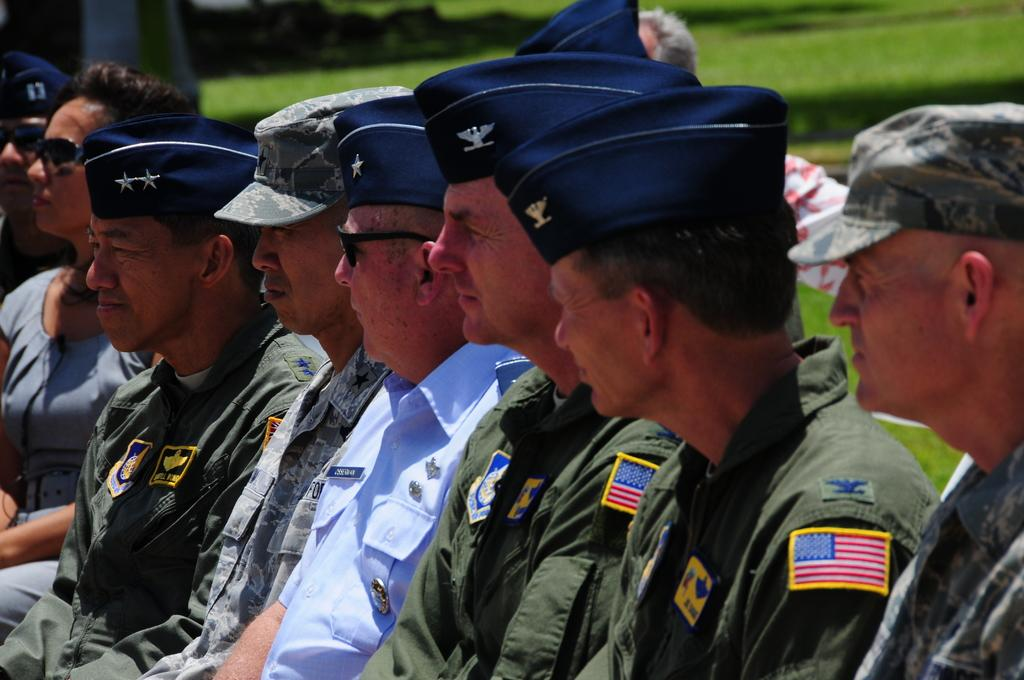How many people are in the image? There are multiple people in the image. What are the people doing in the image? The people are sitting in rows. What are the people wearing in the image? The people are wearing uniforms. What type of surface can be seen in the image? There is grass visible in the image. How many fingers can be seen on the person's hand in the image? There is no specific person's hand or fingers visible in the image; it only shows multiple people sitting in rows wearing uniforms. 